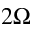<formula> <loc_0><loc_0><loc_500><loc_500>2 \Omega</formula> 